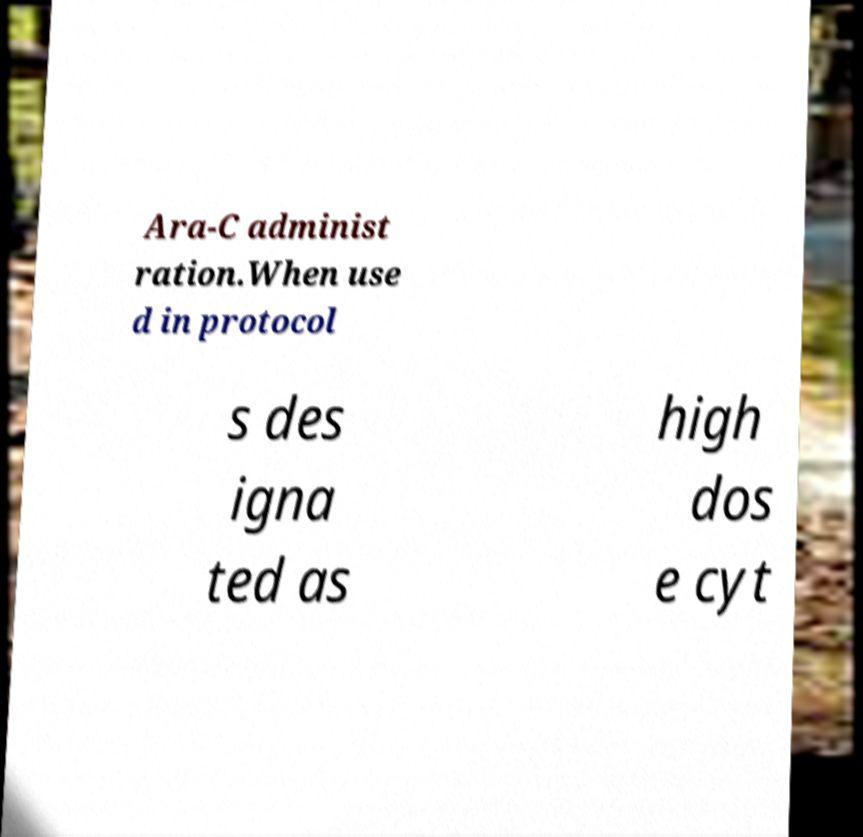Can you read and provide the text displayed in the image?This photo seems to have some interesting text. Can you extract and type it out for me? Ara-C administ ration.When use d in protocol s des igna ted as high dos e cyt 